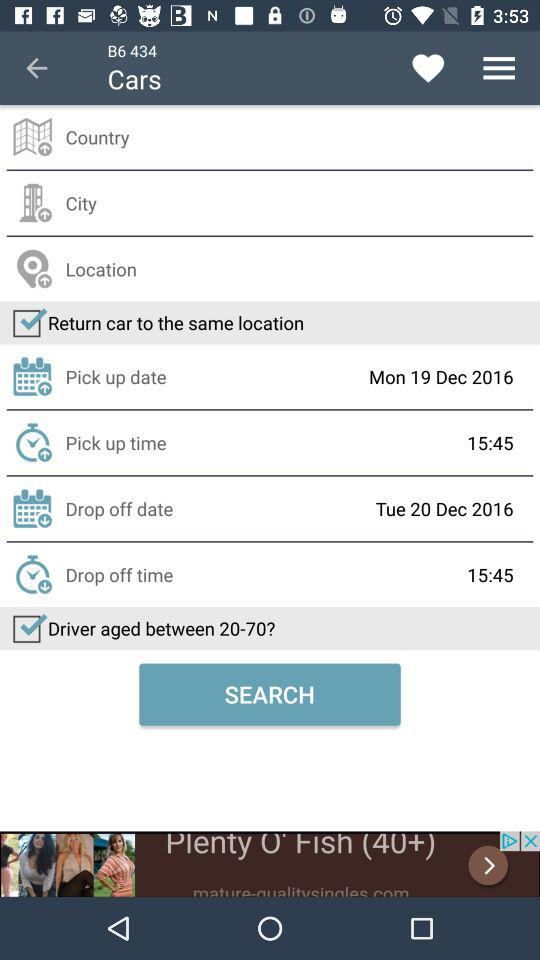How many days difference is there between the pick up and drop off dates?
Answer the question using a single word or phrase. 1 